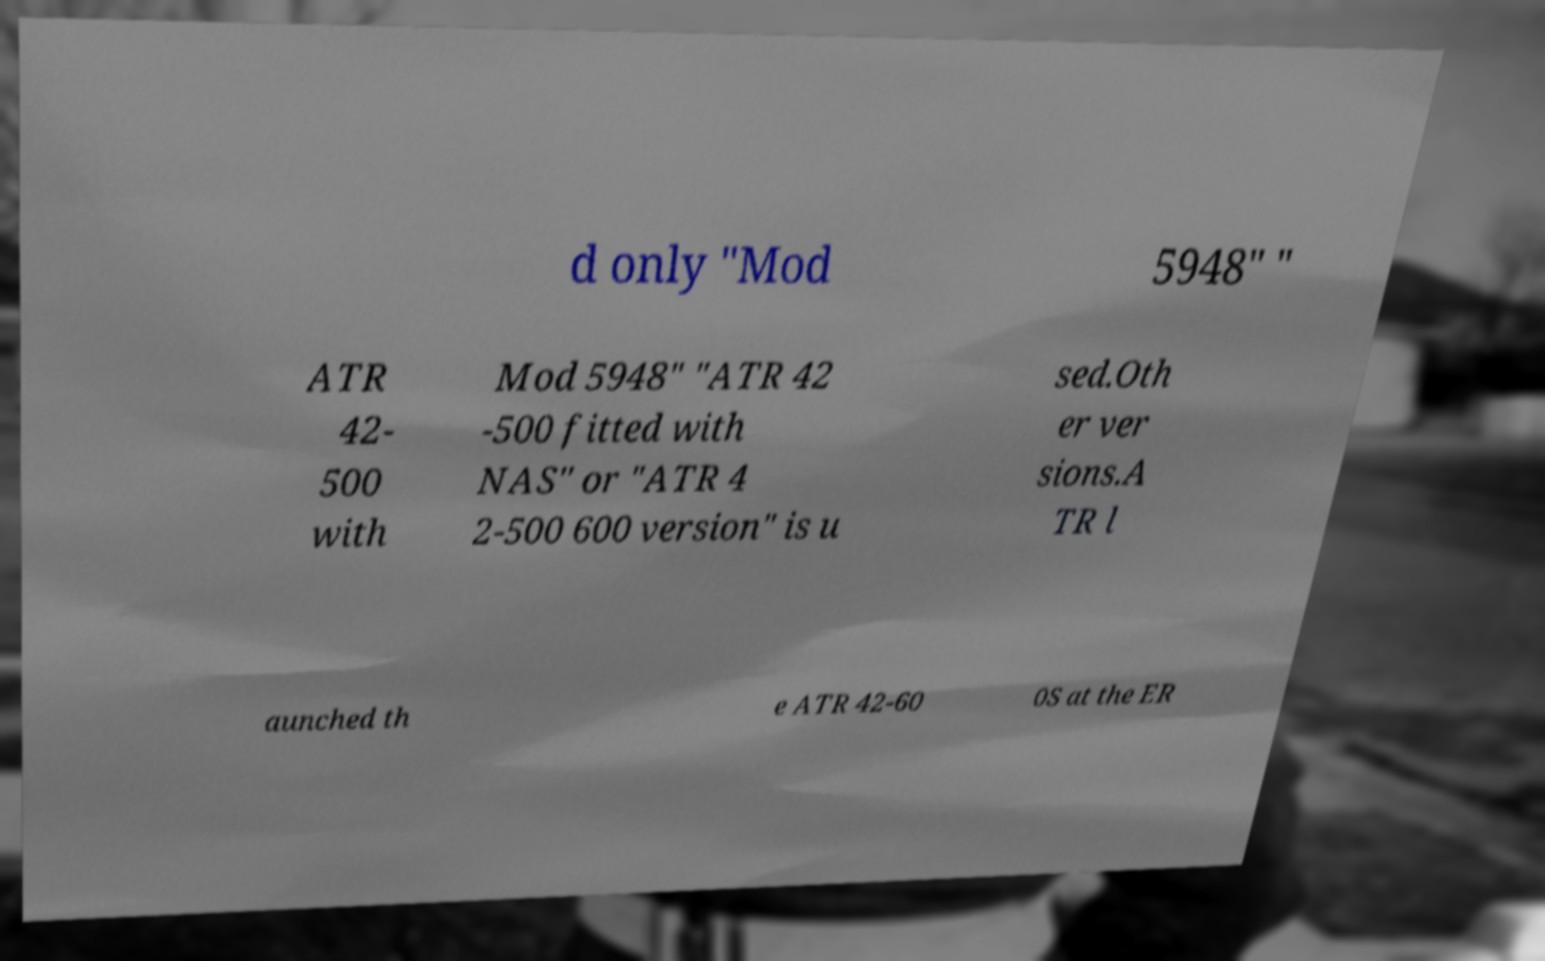What messages or text are displayed in this image? I need them in a readable, typed format. d only "Mod 5948" " ATR 42- 500 with Mod 5948" "ATR 42 -500 fitted with NAS" or "ATR 4 2-500 600 version" is u sed.Oth er ver sions.A TR l aunched th e ATR 42-60 0S at the ER 